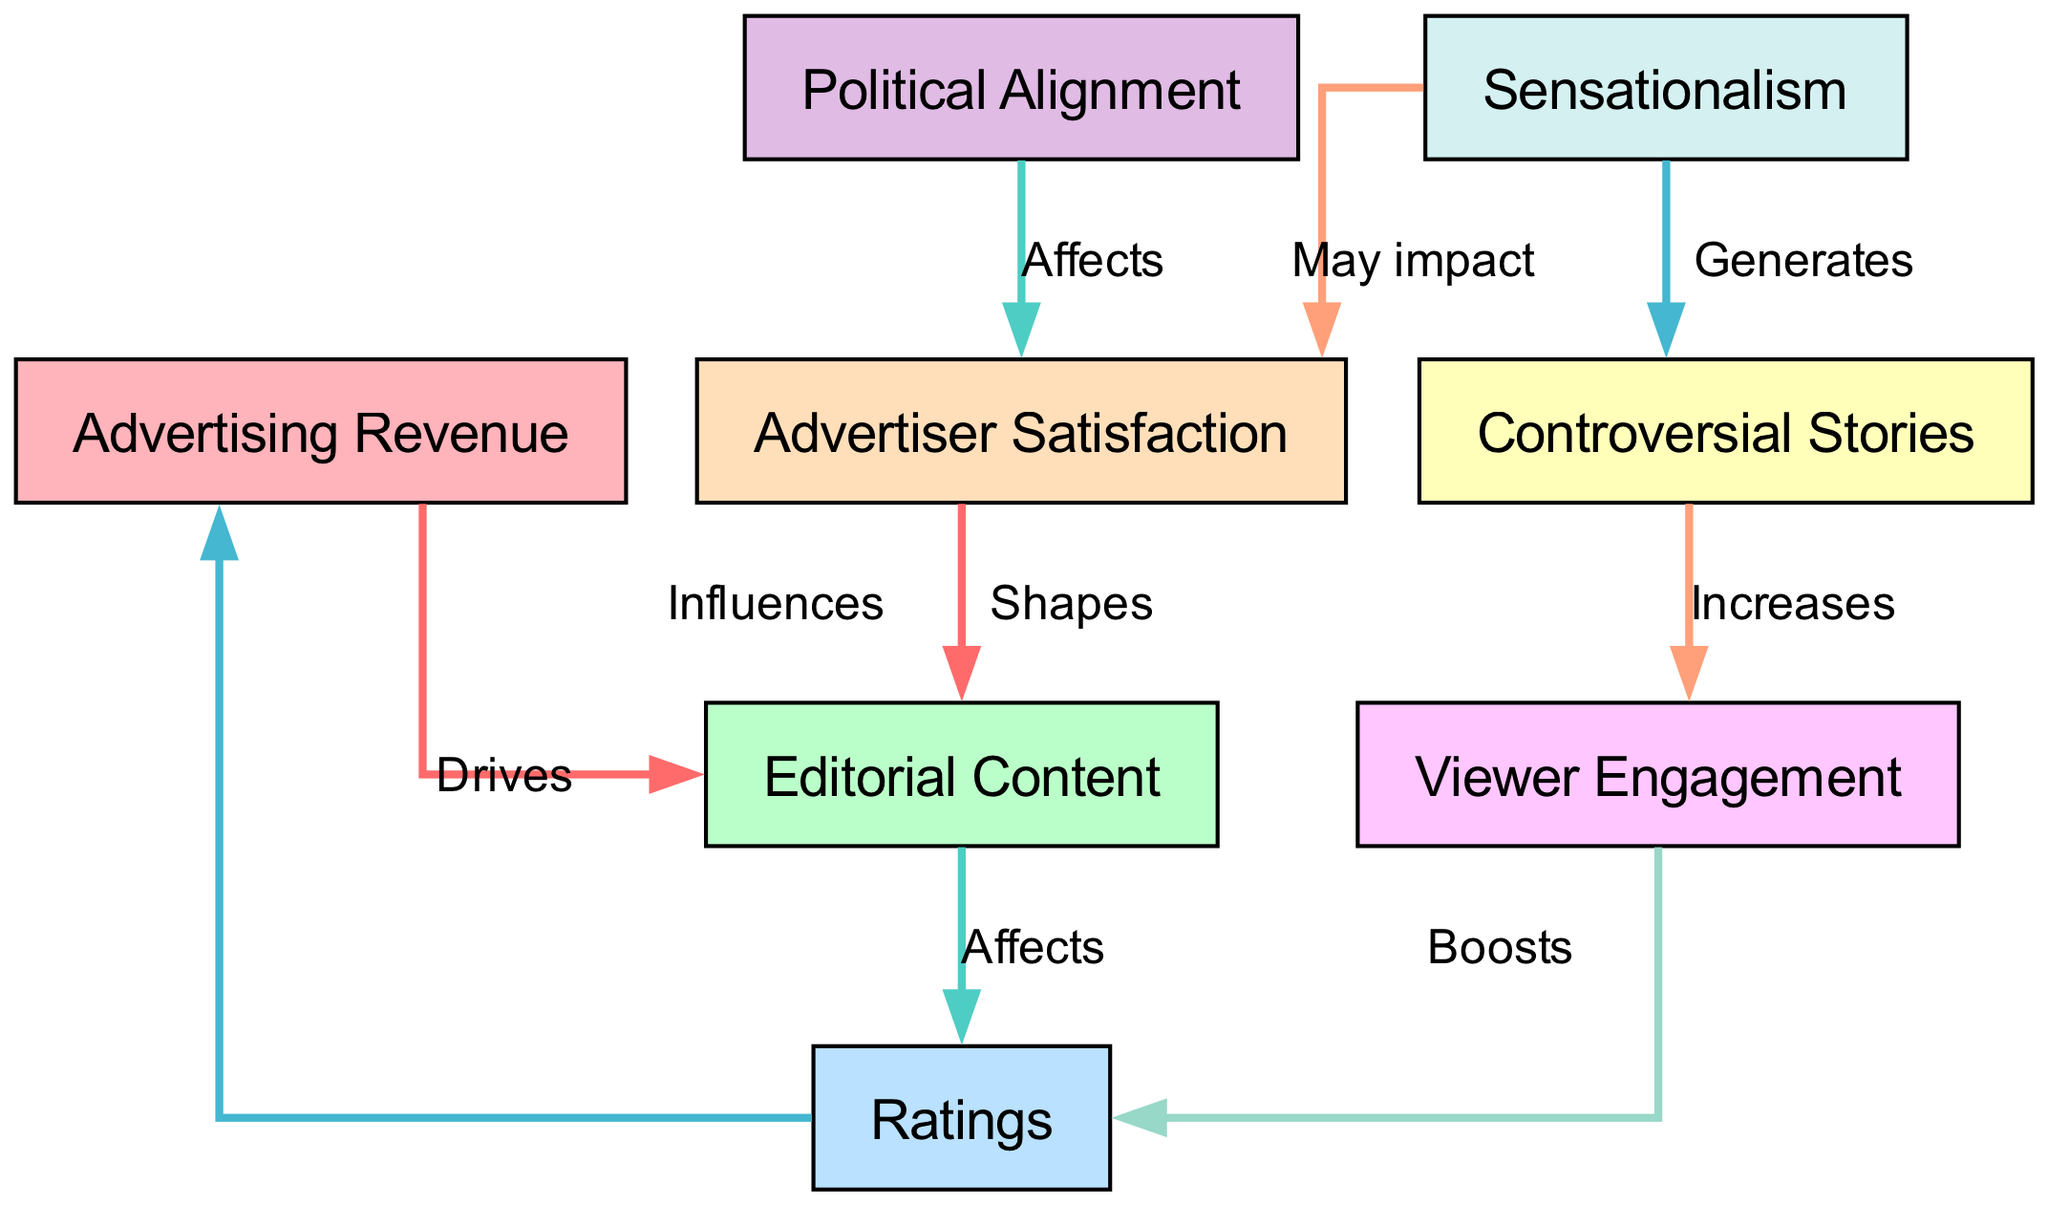What is the total number of nodes in the diagram? The diagram contains a list of nodes, which includes Advertising Revenue, Editorial Content, Ratings, Controversial Stories, Advertiser Satisfaction, Political Alignment, Sensationalism, and Viewer Engagement. Counting these, there are a total of 8 nodes.
Answer: 8 What impacts Advertiser Satisfaction? The diagram shows that Political Alignment affects Advertiser Satisfaction directly. Additionally, Sensationalism may impact Advertiser Satisfaction as well.
Answer: Political Alignment, Sensationalism How does Editorial Content influence Ratings? According to the diagram, there is a direct edge labeled "Affects" that shows that Editorial Content influences Ratings. This means that changes in Editorial Content will directly affect the Ratings.
Answer: Affects Which node is increased by Controversial Stories? The diagram indicates that Controversial Stories increase Viewer Engagement. Therefore, when there are more Controversial Stories, Viewer Engagement also rises.
Answer: Viewer Engagement What is the relationship between Ratings and Advertising Revenue? The diagram shows a directed edge labeled "Drives" originating from Ratings and pointing to Advertising Revenue. This suggests that Ratings have a driving effect on Advertising Revenue, meaning higher Ratings would lead to increased Advertising Revenue.
Answer: Drives How does Viewer Engagement boost Ratings? The flow in the diagram shows that Viewer Engagement leads to higher Ratings through an edge labeled "Boosts." This implies that as Viewer Engagement increases, it has a positive impact on Ratings.
Answer: Boosts What generates Controversial Stories? The diagram includes a relationship where Sensationalism generates Controversial Stories. This means that an increase in Sensationalism will lead to an increase in Controversial Stories in the editorial content.
Answer: Sensationalism Which component does Advertising Revenue influence? The directed edge in the diagram illustrates that Advertising Revenue influences Editorial Content. This means that the revenue received from advertising can impact the types of content featured in the editorial section.
Answer: Editorial Content 